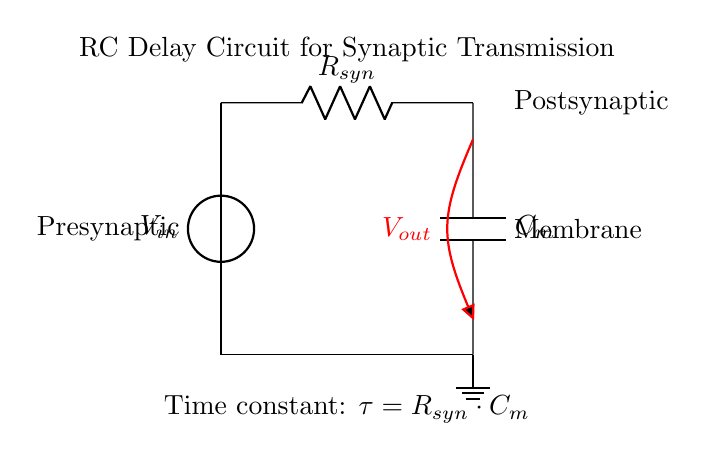What is the voltage input symbol in the circuit? The voltage input symbol is labeled as V in the circuit diagram, indicating the source of the input voltage supplied to the circuit.
Answer: V in What is the component representing synaptic resistance? The component representing synaptic resistance in the circuit is the resistor, which is labeled as R in the diagram.
Answer: R How is the output voltage labeled in the circuit? The output voltage is labeled as V out, indicating the potential difference measured across the capacitor in the circuit.
Answer: V out What does the time constant formula indicate? The time constant formula indicates the relationship between the resistor and capacitor in the circuit, calculated as tau equals R syn times C m.
Answer: tau equals R syn times C m What does the capacitor symbolize in the neural network model? The capacitor symbolizes the membrane capacitance in the circuitry, which is essential for simulating the charge storage within the postsynaptic neuron.
Answer: Membrane capacitance How would an increase in resistance affect the time constant? An increase in resistance would result in a greater time constant, meaning the circuit would take longer to charge or discharge, thus affecting the synaptic transmission simulation.
Answer: Greater time constant What type of circuit is this specifically? This is specifically an RC (Resistor-Capacitor) delay circuit, used to simulate the dynamics of synaptic transmission in neural networks.
Answer: RC delay circuit 